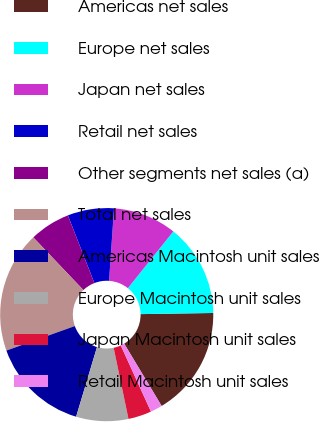<chart> <loc_0><loc_0><loc_500><loc_500><pie_chart><fcel>Americas net sales<fcel>Europe net sales<fcel>Japan net sales<fcel>Retail net sales<fcel>Other segments net sales (a)<fcel>Total net sales<fcel>Americas Macintosh unit sales<fcel>Europe Macintosh unit sales<fcel>Japan Macintosh unit sales<fcel>Retail Macintosh unit sales<nl><fcel>16.63%<fcel>14.01%<fcel>9.65%<fcel>7.03%<fcel>6.16%<fcel>18.38%<fcel>14.89%<fcel>7.91%<fcel>3.54%<fcel>1.8%<nl></chart> 